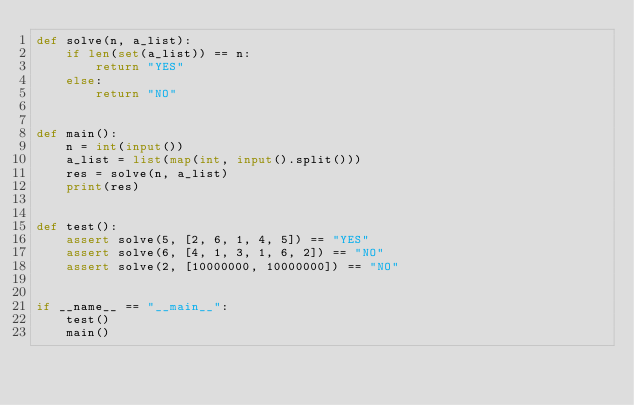<code> <loc_0><loc_0><loc_500><loc_500><_Python_>def solve(n, a_list):
    if len(set(a_list)) == n:
        return "YES"
    else:
        return "NO"


def main():
    n = int(input())
    a_list = list(map(int, input().split()))
    res = solve(n, a_list)
    print(res)


def test():
    assert solve(5, [2, 6, 1, 4, 5]) == "YES"
    assert solve(6, [4, 1, 3, 1, 6, 2]) == "NO"
    assert solve(2, [10000000, 10000000]) == "NO"


if __name__ == "__main__":
    test()
    main()
</code> 